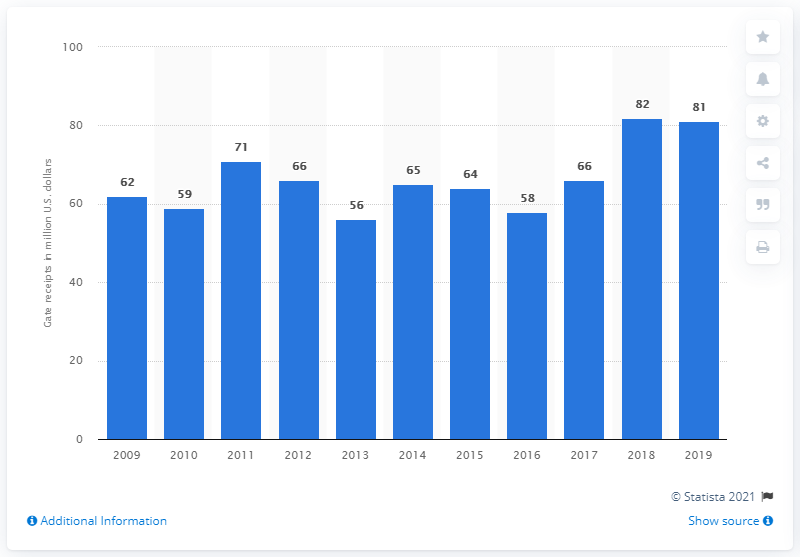Specify some key components in this picture. The gate receipts of the Milwaukee Brewers in 2019 were $81 million. 